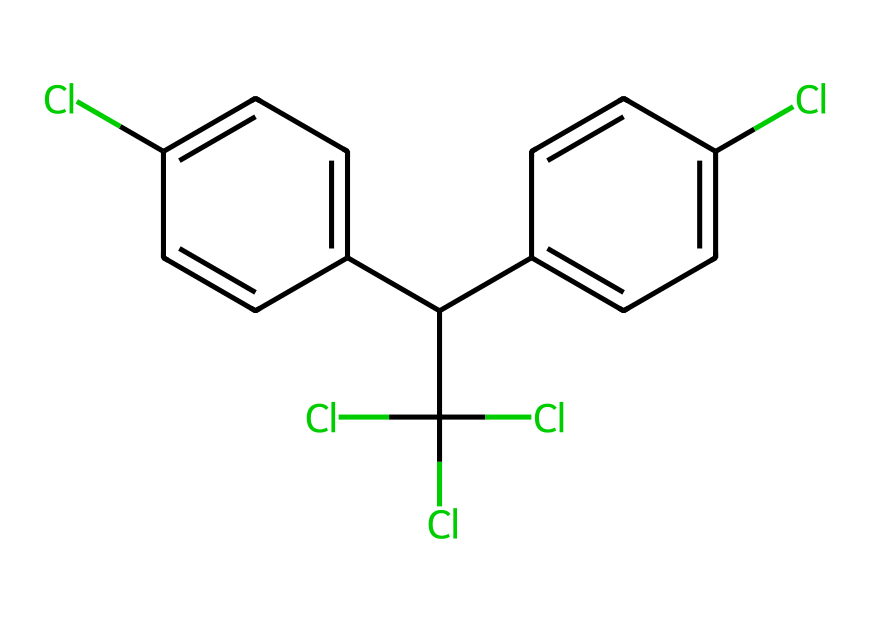What is the molecular formula of DDT? To determine the molecular formula, count the number of each type of atom present in the structure. The SMILES indicates the presence of 14 carbon atoms (C), 9 hydrogen atoms (H), and 4 chlorine atoms (Cl). Thus, the molecular formula is C14H9Cl4.
Answer: C14H9Cl4 How many rings are in the chemical structure of DDT? By examining the structure represented by the SMILES, there are two aromatic rings present in DDT. This can be identified by looking at the presence of two distinct hexagonal ring structures with alternating double bonds in the given chemical.
Answer: 2 How many chlorine atoms are attached to the phenyl rings in DDT? Counting the chlorine atoms associated with the phenyl rings shows that there are two chlorines directly attached to each of the two phenyl rings, for a total of four. This is evidenced by the structure where the Cl atoms are bonded to the carbon atoms that make up the rings.
Answer: 4 What type of pesticide is DDT classified as? DDT is classified as an organochlorine pesticide, which is evident from its heavy reliance on chlorine atoms in its structure and its historical usage in pest control. The presence of chlorine atoms contributes to its effectiveness as an insecticide.
Answer: organochlorine Why is the structure of DDT significant for its persistence in the environment? The structure of DDT contains multiple chlorine atoms integrated into its molecular architecture, which contributes to its lipophilicity and resistance to biodegradation. This structural property means it tends to accumulate in fatty tissues and persists in the environment long after its application, which is a significant concern for ecological health.
Answer: persistence 